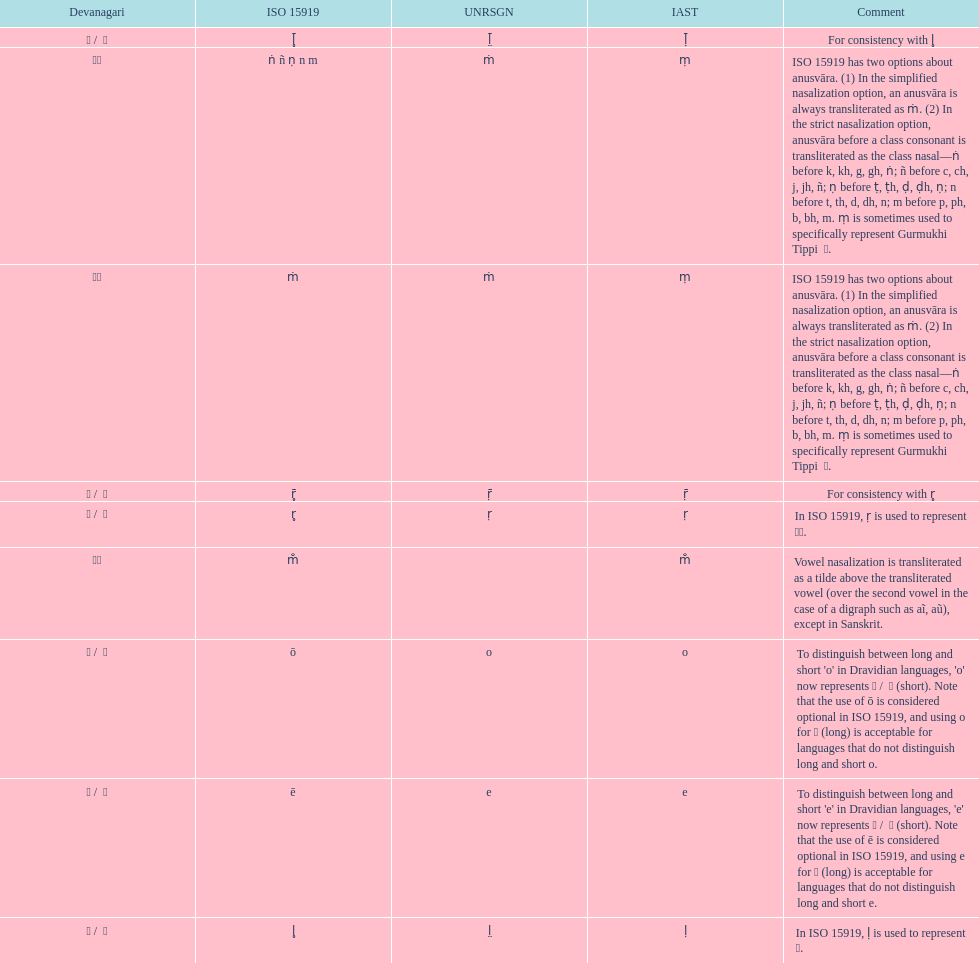What is listed previous to in iso 15919, &#7735; is used to represent &#2355;. under comments? For consistency with r̥. 